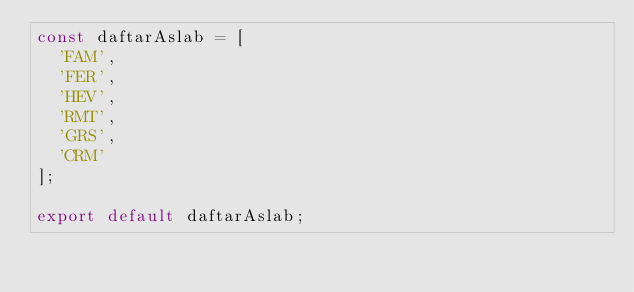<code> <loc_0><loc_0><loc_500><loc_500><_JavaScript_>const daftarAslab = [
  'FAM',
  'FER',
  'HEV',
  'RMT',
  'GRS',
  'CRM'
];

export default daftarAslab;
</code> 